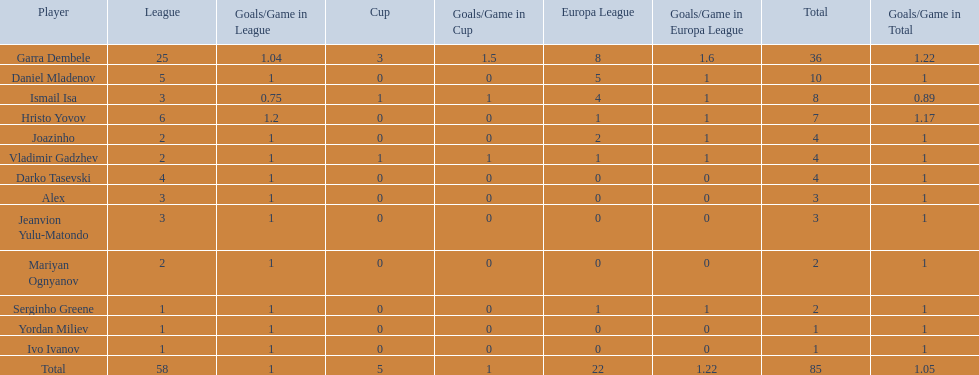What is the sum of the cup total and the europa league total? 27. 